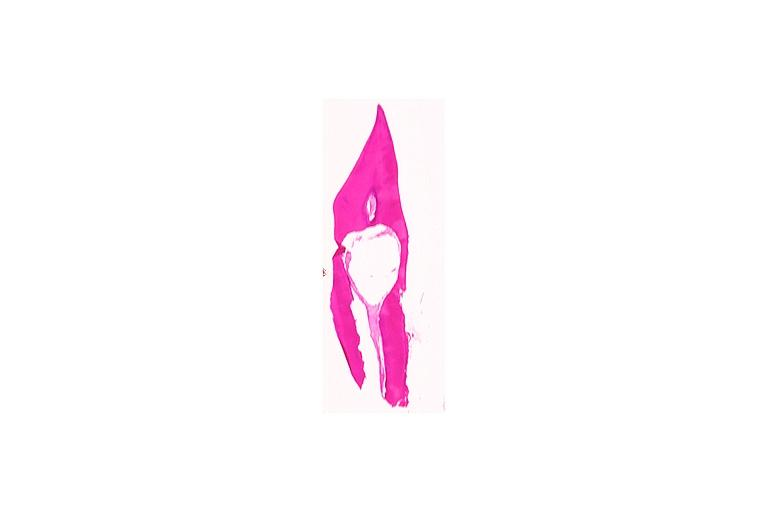where is this?
Answer the question using a single word or phrase. Oral 